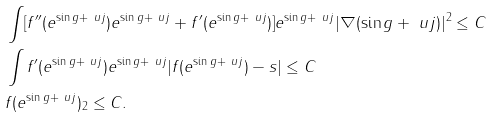Convert formula to latex. <formula><loc_0><loc_0><loc_500><loc_500>& \int [ f ^ { \prime \prime } ( e ^ { \sin g + \ u j } ) e ^ { \sin g + \ u j } + f ^ { \prime } ( e ^ { \sin g + \ u j } ) ] e ^ { \sin g + \ u j } | \nabla ( \sin g + \ u j ) | ^ { 2 } \leq C \\ & \int f ^ { \prime } ( e ^ { \sin g + \ u j } ) e ^ { \sin g + \ u j } | f ( e ^ { \sin g + \ u j } ) - s | \leq C \\ & \| f ( e ^ { \sin g + \ u j } ) \| _ { 2 } \leq C .</formula> 